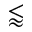Convert formula to latex. <formula><loc_0><loc_0><loc_500><loc_500>\lessapprox</formula> 